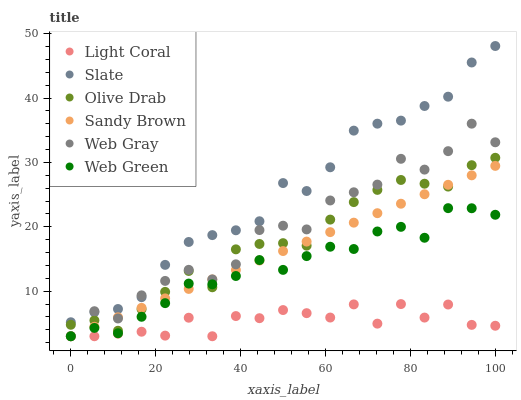Does Light Coral have the minimum area under the curve?
Answer yes or no. Yes. Does Slate have the maximum area under the curve?
Answer yes or no. Yes. Does Web Green have the minimum area under the curve?
Answer yes or no. No. Does Web Green have the maximum area under the curve?
Answer yes or no. No. Is Sandy Brown the smoothest?
Answer yes or no. Yes. Is Web Gray the roughest?
Answer yes or no. Yes. Is Slate the smoothest?
Answer yes or no. No. Is Slate the roughest?
Answer yes or no. No. Does Web Gray have the lowest value?
Answer yes or no. Yes. Does Slate have the lowest value?
Answer yes or no. No. Does Slate have the highest value?
Answer yes or no. Yes. Does Web Green have the highest value?
Answer yes or no. No. Is Web Green less than Slate?
Answer yes or no. Yes. Is Slate greater than Web Green?
Answer yes or no. Yes. Does Sandy Brown intersect Olive Drab?
Answer yes or no. Yes. Is Sandy Brown less than Olive Drab?
Answer yes or no. No. Is Sandy Brown greater than Olive Drab?
Answer yes or no. No. Does Web Green intersect Slate?
Answer yes or no. No. 